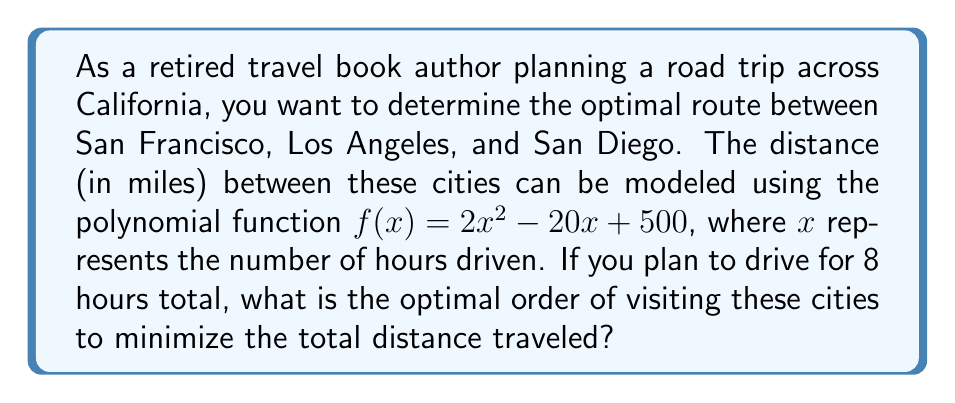What is the answer to this math problem? Let's approach this step-by-step:

1) First, we need to calculate the distances between the cities using the given function $f(x) = 2x^2 - 20x + 500$.

2) The driving times between the cities are approximately:
   - San Francisco to Los Angeles: 6 hours
   - Los Angeles to San Diego: 2 hours
   - San Francisco to San Diego: 8 hours

3) Let's calculate the distances:
   - SF to LA: $f(6) = 2(6)^2 - 20(6) + 500 = 72 - 120 + 500 = 452$ miles
   - LA to SD: $f(2) = 2(2)^2 - 20(2) + 500 = 8 - 40 + 500 = 468$ miles
   - SF to SD: $f(8) = 2(8)^2 - 20(8) + 500 = 128 - 160 + 500 = 468$ miles

4) Now, we need to consider the possible routes:
   a) SF -> LA -> SD: 452 + 468 = 920 miles
   b) SF -> SD -> LA: 468 + 468 = 936 miles
   c) LA -> SF -> SD: 452 + 468 = 920 miles
   d) LA -> SD -> SF: 468 + 468 = 936 miles
   e) SD -> SF -> LA: 468 + 452 = 920 miles
   f) SD -> LA -> SF: 468 + 452 = 920 miles

5) The optimal routes that minimize the total distance are:
   SF -> LA -> SD
   LA -> SF -> SD
   SD -> SF -> LA
   SD -> LA -> SF

   All of these routes result in a total distance of 920 miles.

6) As a travel book author, you might prefer the route that allows you to see the coast throughout the journey. Among the optimal routes, SF -> LA -> SD follows the coastal highway (Pacific Coast Highway) for the majority of the trip.
Answer: San Francisco -> Los Angeles -> San Diego (920 miles) 